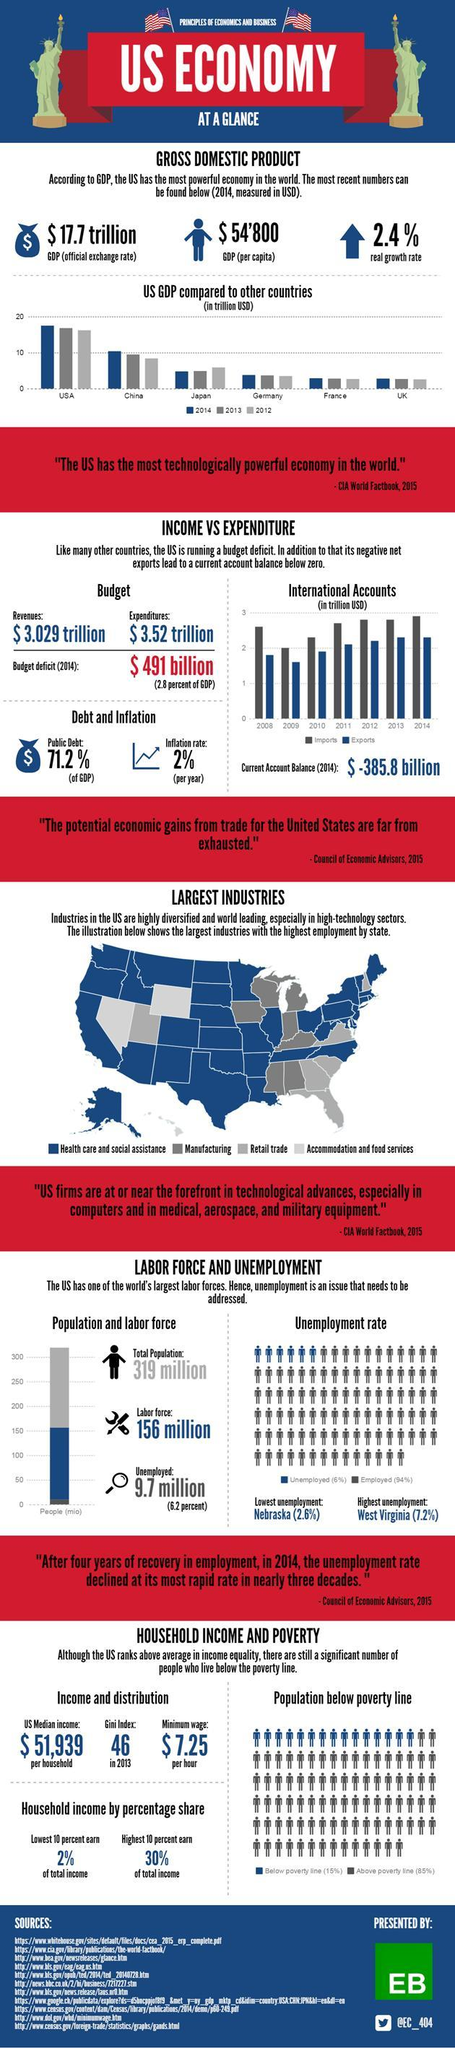What is the real growth rate?
Answer the question with a short phrase. 2.4% What is the Gini index in 20131? 46 What is the public debt? 71.2% 